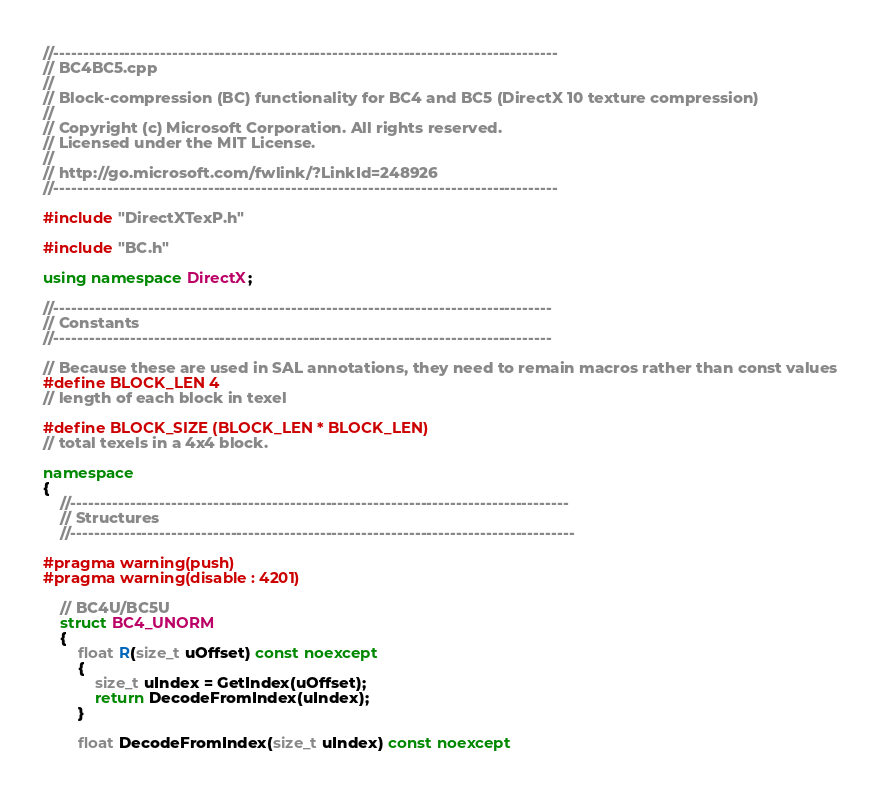<code> <loc_0><loc_0><loc_500><loc_500><_C++_>//-------------------------------------------------------------------------------------
// BC4BC5.cpp
//  
// Block-compression (BC) functionality for BC4 and BC5 (DirectX 10 texture compression)
//
// Copyright (c) Microsoft Corporation. All rights reserved.
// Licensed under the MIT License.
//
// http://go.microsoft.com/fwlink/?LinkId=248926
//-------------------------------------------------------------------------------------

#include "DirectXTexP.h"

#include "BC.h"

using namespace DirectX;

//------------------------------------------------------------------------------------
// Constants
//------------------------------------------------------------------------------------

// Because these are used in SAL annotations, they need to remain macros rather than const values
#define BLOCK_LEN 4
// length of each block in texel

#define BLOCK_SIZE (BLOCK_LEN * BLOCK_LEN)
// total texels in a 4x4 block.

namespace
{
    //------------------------------------------------------------------------------------
    // Structures
    //-------------------------------------------------------------------------------------

#pragma warning(push)
#pragma warning(disable : 4201)

    // BC4U/BC5U
    struct BC4_UNORM
    {
        float R(size_t uOffset) const noexcept
        {
            size_t uIndex = GetIndex(uOffset);
            return DecodeFromIndex(uIndex);
        }

        float DecodeFromIndex(size_t uIndex) const noexcept</code> 